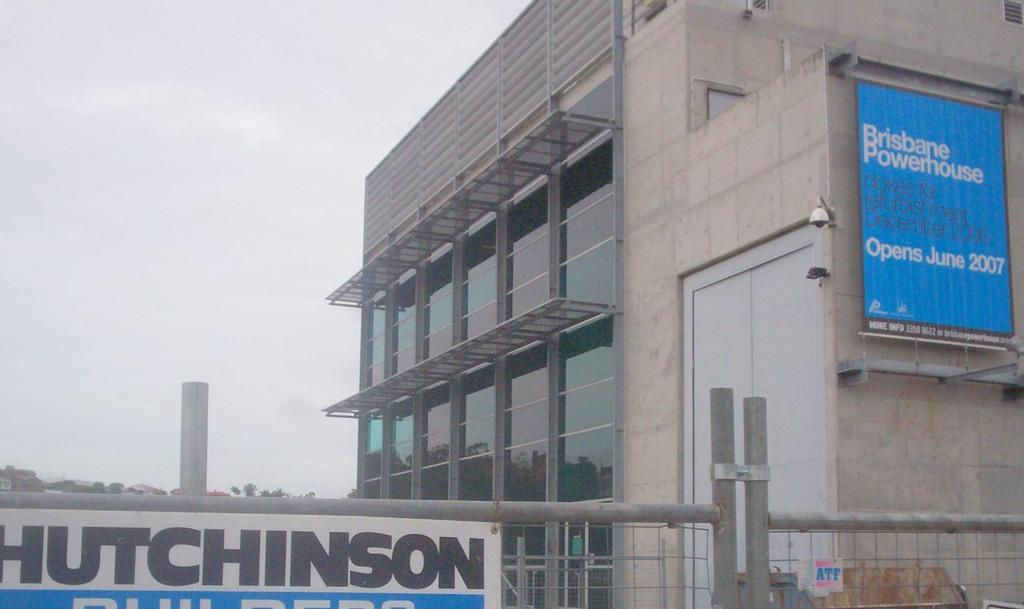What is located at the bottom of the image? There is fencing at the bottom of the image. What can be seen behind the fencing? There is a building behind the fencing. What is visible in the top left side of the image? Clouds and sky are visible in the top left side of the image. How many bones are visible in the image? There are no bones present in the image. What type of map can be seen in the image? There is no map present in the image. 